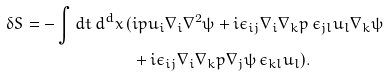<formula> <loc_0><loc_0><loc_500><loc_500>\delta S = - \int d t \, d ^ { d } x \, ( & i p u _ { i } \nabla _ { i } \nabla ^ { 2 } \psi + i \epsilon _ { i j } \nabla _ { i } \nabla _ { k } p \, \epsilon _ { j l } u _ { l } \nabla _ { k } \psi \\ & + i \epsilon _ { i j } \nabla _ { i } \nabla _ { k } p \nabla _ { j } \psi \, \epsilon _ { k l } u _ { l } ) .</formula> 